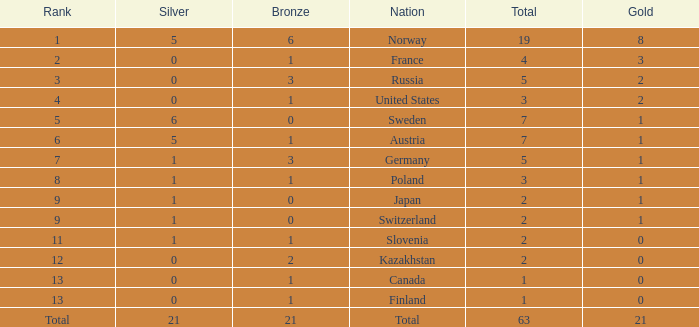I'm looking to parse the entire table for insights. Could you assist me with that? {'header': ['Rank', 'Silver', 'Bronze', 'Nation', 'Total', 'Gold'], 'rows': [['1', '5', '6', 'Norway', '19', '8'], ['2', '0', '1', 'France', '4', '3'], ['3', '0', '3', 'Russia', '5', '2'], ['4', '0', '1', 'United States', '3', '2'], ['5', '6', '0', 'Sweden', '7', '1'], ['6', '5', '1', 'Austria', '7', '1'], ['7', '1', '3', 'Germany', '5', '1'], ['8', '1', '1', 'Poland', '3', '1'], ['9', '1', '0', 'Japan', '2', '1'], ['9', '1', '0', 'Switzerland', '2', '1'], ['11', '1', '1', 'Slovenia', '2', '0'], ['12', '0', '2', 'Kazakhstan', '2', '0'], ['13', '0', '1', 'Canada', '1', '0'], ['13', '0', '1', 'Finland', '1', '0'], ['Total', '21', '21', 'Total', '63', '21']]} What Rank has a gold smaller than 1, and a silver larger than 0? 11.0. 